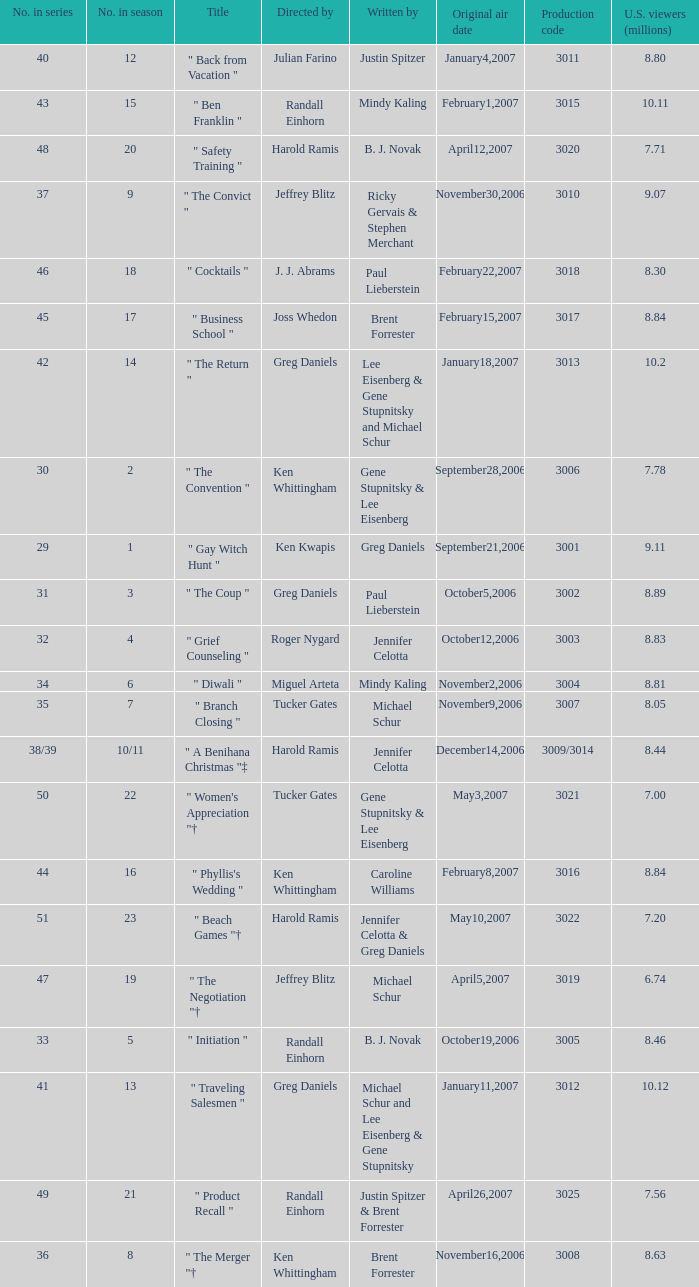Name the number in the series for when the viewers is 7.78 30.0. 